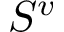<formula> <loc_0><loc_0><loc_500><loc_500>S ^ { v }</formula> 